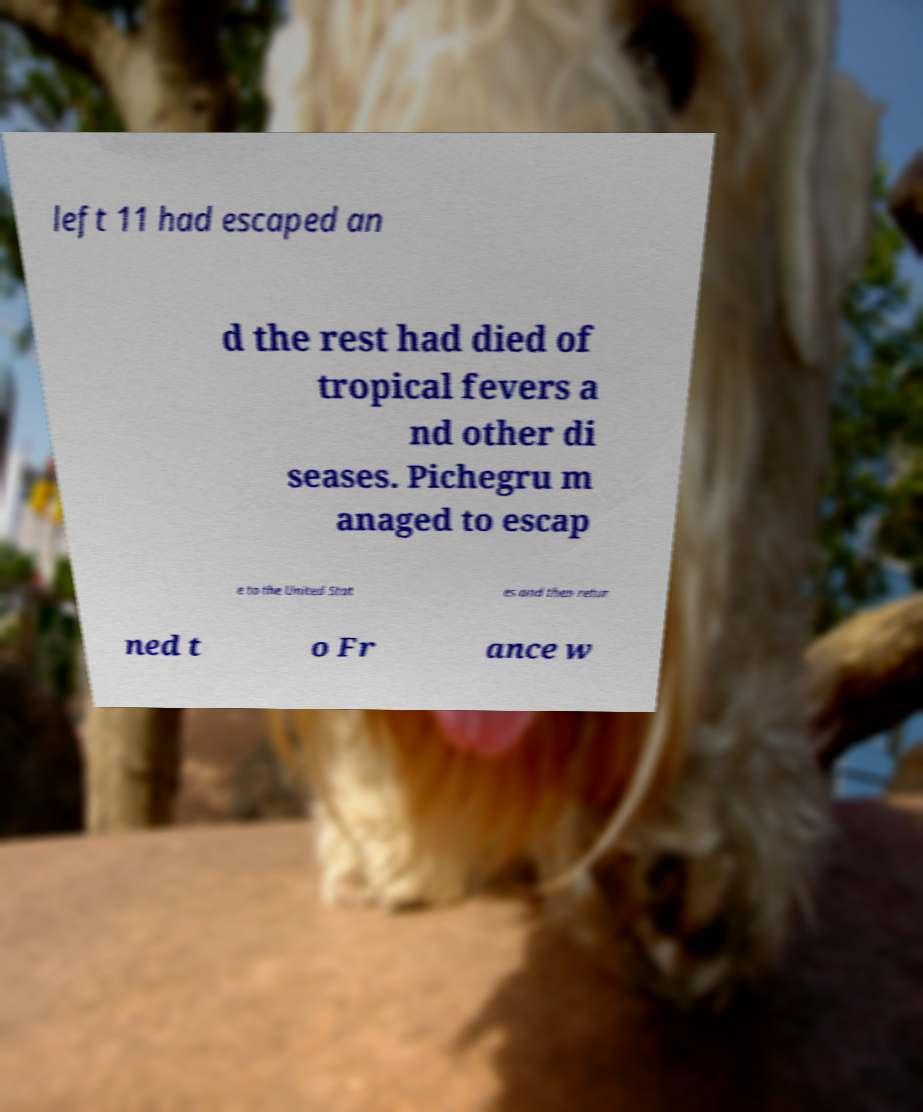Could you extract and type out the text from this image? left 11 had escaped an d the rest had died of tropical fevers a nd other di seases. Pichegru m anaged to escap e to the United Stat es and then retur ned t o Fr ance w 